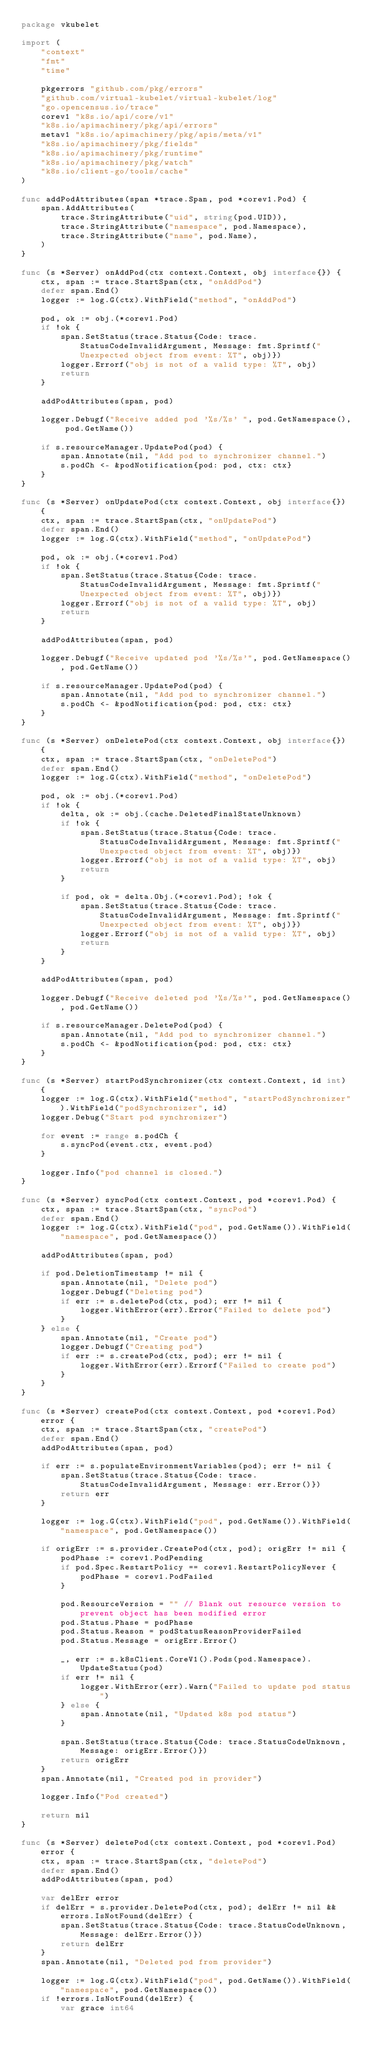<code> <loc_0><loc_0><loc_500><loc_500><_Go_>package vkubelet

import (
	"context"
	"fmt"
	"time"

	pkgerrors "github.com/pkg/errors"
	"github.com/virtual-kubelet/virtual-kubelet/log"
	"go.opencensus.io/trace"
	corev1 "k8s.io/api/core/v1"
	"k8s.io/apimachinery/pkg/api/errors"
	metav1 "k8s.io/apimachinery/pkg/apis/meta/v1"
	"k8s.io/apimachinery/pkg/fields"
	"k8s.io/apimachinery/pkg/runtime"
	"k8s.io/apimachinery/pkg/watch"
	"k8s.io/client-go/tools/cache"
)

func addPodAttributes(span *trace.Span, pod *corev1.Pod) {
	span.AddAttributes(
		trace.StringAttribute("uid", string(pod.UID)),
		trace.StringAttribute("namespace", pod.Namespace),
		trace.StringAttribute("name", pod.Name),
	)
}

func (s *Server) onAddPod(ctx context.Context, obj interface{}) {
	ctx, span := trace.StartSpan(ctx, "onAddPod")
	defer span.End()
	logger := log.G(ctx).WithField("method", "onAddPod")

	pod, ok := obj.(*corev1.Pod)
	if !ok {
		span.SetStatus(trace.Status{Code: trace.StatusCodeInvalidArgument, Message: fmt.Sprintf("Unexpected object from event: %T", obj)})
		logger.Errorf("obj is not of a valid type: %T", obj)
		return
	}

	addPodAttributes(span, pod)

	logger.Debugf("Receive added pod '%s/%s' ", pod.GetNamespace(), pod.GetName())

	if s.resourceManager.UpdatePod(pod) {
		span.Annotate(nil, "Add pod to synchronizer channel.")
		s.podCh <- &podNotification{pod: pod, ctx: ctx}
	}
}

func (s *Server) onUpdatePod(ctx context.Context, obj interface{}) {
	ctx, span := trace.StartSpan(ctx, "onUpdatePod")
	defer span.End()
	logger := log.G(ctx).WithField("method", "onUpdatePod")

	pod, ok := obj.(*corev1.Pod)
	if !ok {
		span.SetStatus(trace.Status{Code: trace.StatusCodeInvalidArgument, Message: fmt.Sprintf("Unexpected object from event: %T", obj)})
		logger.Errorf("obj is not of a valid type: %T", obj)
		return
	}

	addPodAttributes(span, pod)

	logger.Debugf("Receive updated pod '%s/%s'", pod.GetNamespace(), pod.GetName())

	if s.resourceManager.UpdatePod(pod) {
		span.Annotate(nil, "Add pod to synchronizer channel.")
		s.podCh <- &podNotification{pod: pod, ctx: ctx}
	}
}

func (s *Server) onDeletePod(ctx context.Context, obj interface{}) {
	ctx, span := trace.StartSpan(ctx, "onDeletePod")
	defer span.End()
	logger := log.G(ctx).WithField("method", "onDeletePod")

	pod, ok := obj.(*corev1.Pod)
	if !ok {
		delta, ok := obj.(cache.DeletedFinalStateUnknown)
		if !ok {
			span.SetStatus(trace.Status{Code: trace.StatusCodeInvalidArgument, Message: fmt.Sprintf("Unexpected object from event: %T", obj)})
			logger.Errorf("obj is not of a valid type: %T", obj)
			return
		}

		if pod, ok = delta.Obj.(*corev1.Pod); !ok {
			span.SetStatus(trace.Status{Code: trace.StatusCodeInvalidArgument, Message: fmt.Sprintf("Unexpected object from event: %T", obj)})
			logger.Errorf("obj is not of a valid type: %T", obj)
			return
		}
	}

	addPodAttributes(span, pod)

	logger.Debugf("Receive deleted pod '%s/%s'", pod.GetNamespace(), pod.GetName())

	if s.resourceManager.DeletePod(pod) {
		span.Annotate(nil, "Add pod to synchronizer channel.")
		s.podCh <- &podNotification{pod: pod, ctx: ctx}
	}
}

func (s *Server) startPodSynchronizer(ctx context.Context, id int) {
	logger := log.G(ctx).WithField("method", "startPodSynchronizer").WithField("podSynchronizer", id)
	logger.Debug("Start pod synchronizer")

	for event := range s.podCh {
		s.syncPod(event.ctx, event.pod)
	}

	logger.Info("pod channel is closed.")
}

func (s *Server) syncPod(ctx context.Context, pod *corev1.Pod) {
	ctx, span := trace.StartSpan(ctx, "syncPod")
	defer span.End()
	logger := log.G(ctx).WithField("pod", pod.GetName()).WithField("namespace", pod.GetNamespace())

	addPodAttributes(span, pod)

	if pod.DeletionTimestamp != nil {
		span.Annotate(nil, "Delete pod")
		logger.Debugf("Deleting pod")
		if err := s.deletePod(ctx, pod); err != nil {
			logger.WithError(err).Error("Failed to delete pod")
		}
	} else {
		span.Annotate(nil, "Create pod")
		logger.Debugf("Creating pod")
		if err := s.createPod(ctx, pod); err != nil {
			logger.WithError(err).Errorf("Failed to create pod")
		}
	}
}

func (s *Server) createPod(ctx context.Context, pod *corev1.Pod) error {
	ctx, span := trace.StartSpan(ctx, "createPod")
	defer span.End()
	addPodAttributes(span, pod)

	if err := s.populateEnvironmentVariables(pod); err != nil {
		span.SetStatus(trace.Status{Code: trace.StatusCodeInvalidArgument, Message: err.Error()})
		return err
	}

	logger := log.G(ctx).WithField("pod", pod.GetName()).WithField("namespace", pod.GetNamespace())

	if origErr := s.provider.CreatePod(ctx, pod); origErr != nil {
		podPhase := corev1.PodPending
		if pod.Spec.RestartPolicy == corev1.RestartPolicyNever {
			podPhase = corev1.PodFailed
		}

		pod.ResourceVersion = "" // Blank out resource version to prevent object has been modified error
		pod.Status.Phase = podPhase
		pod.Status.Reason = podStatusReasonProviderFailed
		pod.Status.Message = origErr.Error()

		_, err := s.k8sClient.CoreV1().Pods(pod.Namespace).UpdateStatus(pod)
		if err != nil {
			logger.WithError(err).Warn("Failed to update pod status")
		} else {
			span.Annotate(nil, "Updated k8s pod status")
		}

		span.SetStatus(trace.Status{Code: trace.StatusCodeUnknown, Message: origErr.Error()})
		return origErr
	}
	span.Annotate(nil, "Created pod in provider")

	logger.Info("Pod created")

	return nil
}

func (s *Server) deletePod(ctx context.Context, pod *corev1.Pod) error {
	ctx, span := trace.StartSpan(ctx, "deletePod")
	defer span.End()
	addPodAttributes(span, pod)

	var delErr error
	if delErr = s.provider.DeletePod(ctx, pod); delErr != nil && errors.IsNotFound(delErr) {
		span.SetStatus(trace.Status{Code: trace.StatusCodeUnknown, Message: delErr.Error()})
		return delErr
	}
	span.Annotate(nil, "Deleted pod from provider")

	logger := log.G(ctx).WithField("pod", pod.GetName()).WithField("namespace", pod.GetNamespace())
	if !errors.IsNotFound(delErr) {
		var grace int64</code> 